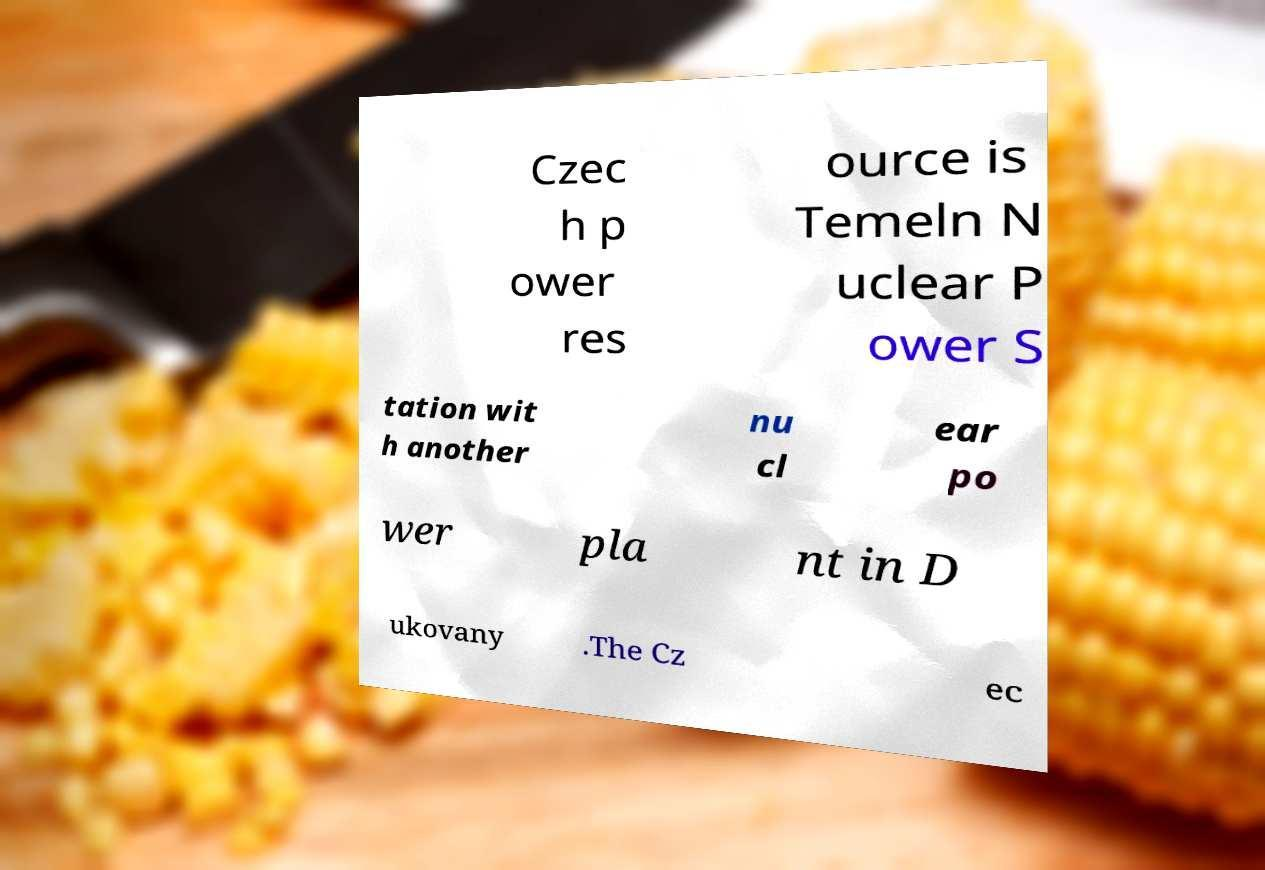Could you assist in decoding the text presented in this image and type it out clearly? Czec h p ower res ource is Temeln N uclear P ower S tation wit h another nu cl ear po wer pla nt in D ukovany .The Cz ec 